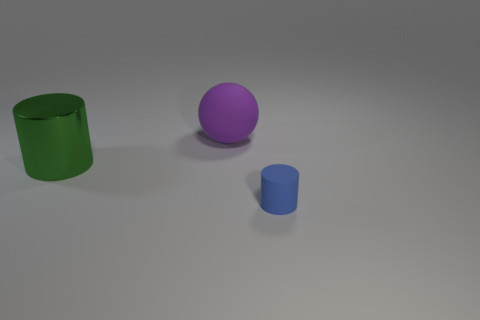Add 3 tiny brown metallic blocks. How many objects exist? 6 Subtract all spheres. How many objects are left? 2 Subtract all big shiny things. Subtract all big gray things. How many objects are left? 2 Add 3 purple rubber things. How many purple rubber things are left? 4 Add 1 large green metal things. How many large green metal things exist? 2 Subtract 0 yellow balls. How many objects are left? 3 